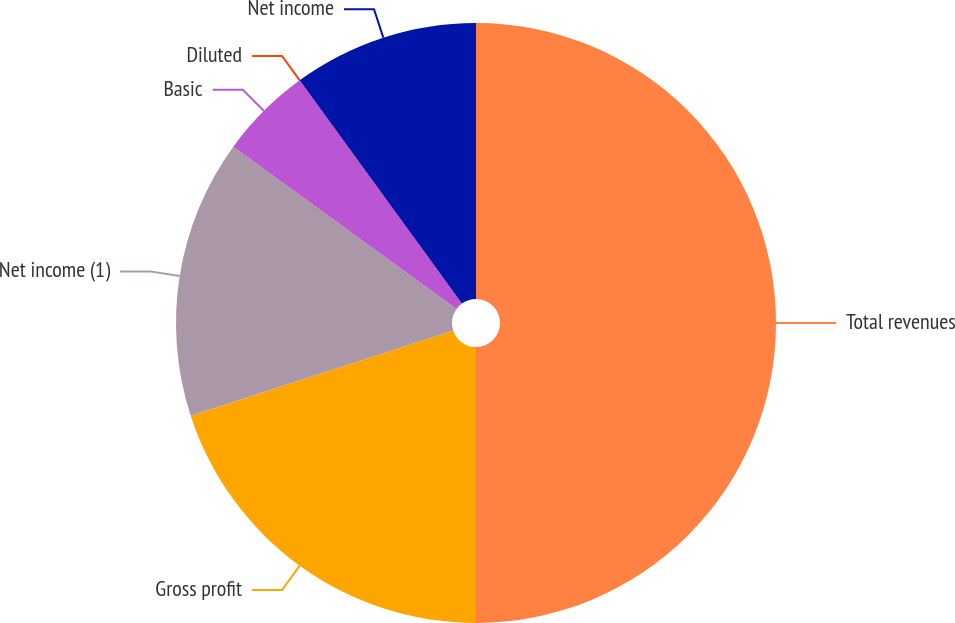<chart> <loc_0><loc_0><loc_500><loc_500><pie_chart><fcel>Total revenues<fcel>Gross profit<fcel>Net income (1)<fcel>Basic<fcel>Diluted<fcel>Net income<nl><fcel>50.0%<fcel>20.0%<fcel>15.0%<fcel>5.0%<fcel>0.0%<fcel>10.0%<nl></chart> 